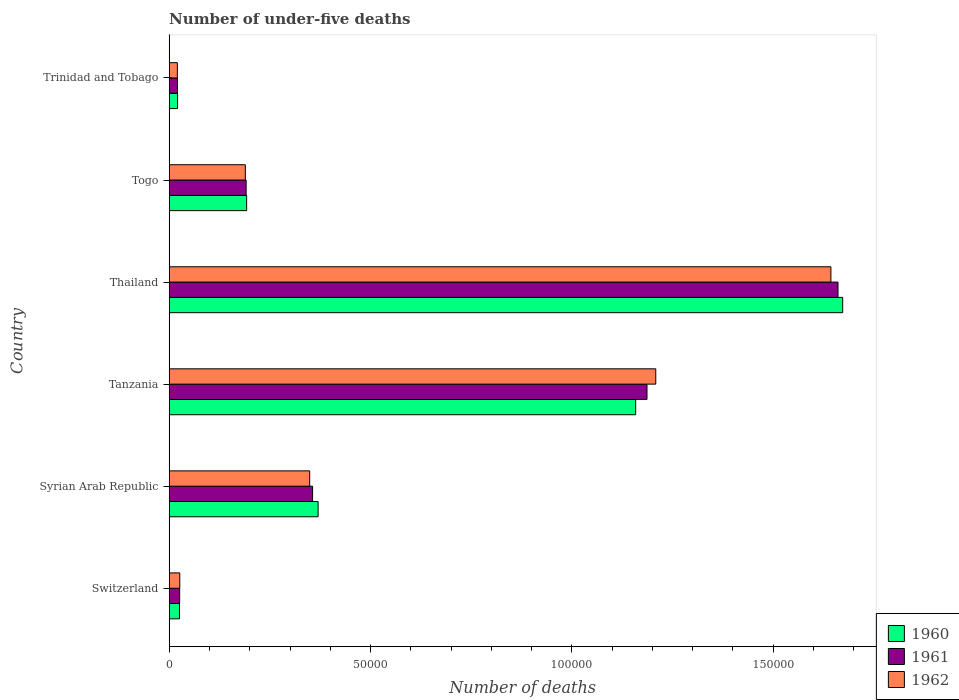Are the number of bars on each tick of the Y-axis equal?
Your answer should be very brief. Yes. How many bars are there on the 2nd tick from the bottom?
Your answer should be compact. 3. What is the label of the 2nd group of bars from the top?
Offer a terse response. Togo. What is the number of under-five deaths in 1962 in Thailand?
Your response must be concise. 1.64e+05. Across all countries, what is the maximum number of under-five deaths in 1961?
Your answer should be very brief. 1.66e+05. Across all countries, what is the minimum number of under-five deaths in 1962?
Offer a terse response. 2020. In which country was the number of under-five deaths in 1961 maximum?
Offer a very short reply. Thailand. In which country was the number of under-five deaths in 1961 minimum?
Keep it short and to the point. Trinidad and Tobago. What is the total number of under-five deaths in 1960 in the graph?
Your answer should be compact. 3.44e+05. What is the difference between the number of under-five deaths in 1961 in Switzerland and that in Tanzania?
Your answer should be compact. -1.16e+05. What is the difference between the number of under-five deaths in 1960 in Thailand and the number of under-five deaths in 1962 in Tanzania?
Provide a succinct answer. 4.64e+04. What is the average number of under-five deaths in 1962 per country?
Give a very brief answer. 5.73e+04. What is the difference between the number of under-five deaths in 1962 and number of under-five deaths in 1961 in Thailand?
Your answer should be compact. -1764. What is the ratio of the number of under-five deaths in 1962 in Switzerland to that in Tanzania?
Provide a short and direct response. 0.02. Is the difference between the number of under-five deaths in 1962 in Thailand and Togo greater than the difference between the number of under-five deaths in 1961 in Thailand and Togo?
Your response must be concise. No. What is the difference between the highest and the second highest number of under-five deaths in 1960?
Make the answer very short. 5.14e+04. What is the difference between the highest and the lowest number of under-five deaths in 1962?
Offer a terse response. 1.62e+05. Is the sum of the number of under-five deaths in 1962 in Syrian Arab Republic and Tanzania greater than the maximum number of under-five deaths in 1960 across all countries?
Your answer should be very brief. No. What does the 1st bar from the top in Syrian Arab Republic represents?
Keep it short and to the point. 1962. Is it the case that in every country, the sum of the number of under-five deaths in 1961 and number of under-five deaths in 1962 is greater than the number of under-five deaths in 1960?
Your response must be concise. Yes. Are all the bars in the graph horizontal?
Give a very brief answer. Yes. How many countries are there in the graph?
Give a very brief answer. 6. Does the graph contain any zero values?
Make the answer very short. No. Where does the legend appear in the graph?
Give a very brief answer. Bottom right. How many legend labels are there?
Your answer should be compact. 3. What is the title of the graph?
Your answer should be compact. Number of under-five deaths. Does "2015" appear as one of the legend labels in the graph?
Give a very brief answer. No. What is the label or title of the X-axis?
Your response must be concise. Number of deaths. What is the Number of deaths in 1960 in Switzerland?
Give a very brief answer. 2549. What is the Number of deaths in 1961 in Switzerland?
Your answer should be compact. 2598. What is the Number of deaths of 1962 in Switzerland?
Your response must be concise. 2625. What is the Number of deaths of 1960 in Syrian Arab Republic?
Keep it short and to the point. 3.70e+04. What is the Number of deaths in 1961 in Syrian Arab Republic?
Ensure brevity in your answer.  3.56e+04. What is the Number of deaths of 1962 in Syrian Arab Republic?
Your answer should be very brief. 3.49e+04. What is the Number of deaths of 1960 in Tanzania?
Keep it short and to the point. 1.16e+05. What is the Number of deaths in 1961 in Tanzania?
Offer a very short reply. 1.19e+05. What is the Number of deaths in 1962 in Tanzania?
Make the answer very short. 1.21e+05. What is the Number of deaths of 1960 in Thailand?
Provide a short and direct response. 1.67e+05. What is the Number of deaths in 1961 in Thailand?
Your response must be concise. 1.66e+05. What is the Number of deaths in 1962 in Thailand?
Make the answer very short. 1.64e+05. What is the Number of deaths in 1960 in Togo?
Your answer should be very brief. 1.92e+04. What is the Number of deaths of 1961 in Togo?
Make the answer very short. 1.91e+04. What is the Number of deaths of 1962 in Togo?
Offer a very short reply. 1.89e+04. What is the Number of deaths of 1960 in Trinidad and Tobago?
Your response must be concise. 2077. What is the Number of deaths in 1961 in Trinidad and Tobago?
Provide a succinct answer. 2047. What is the Number of deaths of 1962 in Trinidad and Tobago?
Provide a short and direct response. 2020. Across all countries, what is the maximum Number of deaths in 1960?
Offer a very short reply. 1.67e+05. Across all countries, what is the maximum Number of deaths in 1961?
Your answer should be very brief. 1.66e+05. Across all countries, what is the maximum Number of deaths in 1962?
Offer a terse response. 1.64e+05. Across all countries, what is the minimum Number of deaths in 1960?
Give a very brief answer. 2077. Across all countries, what is the minimum Number of deaths of 1961?
Your answer should be compact. 2047. Across all countries, what is the minimum Number of deaths in 1962?
Give a very brief answer. 2020. What is the total Number of deaths of 1960 in the graph?
Your answer should be compact. 3.44e+05. What is the total Number of deaths in 1961 in the graph?
Your response must be concise. 3.44e+05. What is the total Number of deaths of 1962 in the graph?
Provide a succinct answer. 3.44e+05. What is the difference between the Number of deaths of 1960 in Switzerland and that in Syrian Arab Republic?
Offer a terse response. -3.44e+04. What is the difference between the Number of deaths of 1961 in Switzerland and that in Syrian Arab Republic?
Give a very brief answer. -3.30e+04. What is the difference between the Number of deaths in 1962 in Switzerland and that in Syrian Arab Republic?
Give a very brief answer. -3.23e+04. What is the difference between the Number of deaths of 1960 in Switzerland and that in Tanzania?
Make the answer very short. -1.13e+05. What is the difference between the Number of deaths in 1961 in Switzerland and that in Tanzania?
Your answer should be very brief. -1.16e+05. What is the difference between the Number of deaths in 1962 in Switzerland and that in Tanzania?
Keep it short and to the point. -1.18e+05. What is the difference between the Number of deaths of 1960 in Switzerland and that in Thailand?
Provide a succinct answer. -1.65e+05. What is the difference between the Number of deaths in 1961 in Switzerland and that in Thailand?
Your answer should be compact. -1.63e+05. What is the difference between the Number of deaths of 1962 in Switzerland and that in Thailand?
Provide a short and direct response. -1.62e+05. What is the difference between the Number of deaths in 1960 in Switzerland and that in Togo?
Keep it short and to the point. -1.67e+04. What is the difference between the Number of deaths in 1961 in Switzerland and that in Togo?
Ensure brevity in your answer.  -1.65e+04. What is the difference between the Number of deaths in 1962 in Switzerland and that in Togo?
Make the answer very short. -1.63e+04. What is the difference between the Number of deaths of 1960 in Switzerland and that in Trinidad and Tobago?
Offer a terse response. 472. What is the difference between the Number of deaths of 1961 in Switzerland and that in Trinidad and Tobago?
Offer a very short reply. 551. What is the difference between the Number of deaths in 1962 in Switzerland and that in Trinidad and Tobago?
Keep it short and to the point. 605. What is the difference between the Number of deaths in 1960 in Syrian Arab Republic and that in Tanzania?
Provide a short and direct response. -7.89e+04. What is the difference between the Number of deaths in 1961 in Syrian Arab Republic and that in Tanzania?
Provide a succinct answer. -8.30e+04. What is the difference between the Number of deaths of 1962 in Syrian Arab Republic and that in Tanzania?
Provide a succinct answer. -8.59e+04. What is the difference between the Number of deaths in 1960 in Syrian Arab Republic and that in Thailand?
Your response must be concise. -1.30e+05. What is the difference between the Number of deaths in 1961 in Syrian Arab Republic and that in Thailand?
Your response must be concise. -1.30e+05. What is the difference between the Number of deaths in 1962 in Syrian Arab Republic and that in Thailand?
Your answer should be very brief. -1.29e+05. What is the difference between the Number of deaths of 1960 in Syrian Arab Republic and that in Togo?
Your response must be concise. 1.78e+04. What is the difference between the Number of deaths in 1961 in Syrian Arab Republic and that in Togo?
Your answer should be compact. 1.65e+04. What is the difference between the Number of deaths of 1962 in Syrian Arab Republic and that in Togo?
Your response must be concise. 1.60e+04. What is the difference between the Number of deaths in 1960 in Syrian Arab Republic and that in Trinidad and Tobago?
Your response must be concise. 3.49e+04. What is the difference between the Number of deaths of 1961 in Syrian Arab Republic and that in Trinidad and Tobago?
Your response must be concise. 3.36e+04. What is the difference between the Number of deaths in 1962 in Syrian Arab Republic and that in Trinidad and Tobago?
Ensure brevity in your answer.  3.29e+04. What is the difference between the Number of deaths in 1960 in Tanzania and that in Thailand?
Ensure brevity in your answer.  -5.14e+04. What is the difference between the Number of deaths in 1961 in Tanzania and that in Thailand?
Give a very brief answer. -4.74e+04. What is the difference between the Number of deaths of 1962 in Tanzania and that in Thailand?
Offer a very short reply. -4.35e+04. What is the difference between the Number of deaths in 1960 in Tanzania and that in Togo?
Your response must be concise. 9.66e+04. What is the difference between the Number of deaths of 1961 in Tanzania and that in Togo?
Your answer should be very brief. 9.95e+04. What is the difference between the Number of deaths in 1962 in Tanzania and that in Togo?
Your answer should be compact. 1.02e+05. What is the difference between the Number of deaths of 1960 in Tanzania and that in Trinidad and Tobago?
Offer a very short reply. 1.14e+05. What is the difference between the Number of deaths in 1961 in Tanzania and that in Trinidad and Tobago?
Give a very brief answer. 1.17e+05. What is the difference between the Number of deaths of 1962 in Tanzania and that in Trinidad and Tobago?
Make the answer very short. 1.19e+05. What is the difference between the Number of deaths of 1960 in Thailand and that in Togo?
Provide a succinct answer. 1.48e+05. What is the difference between the Number of deaths in 1961 in Thailand and that in Togo?
Keep it short and to the point. 1.47e+05. What is the difference between the Number of deaths in 1962 in Thailand and that in Togo?
Provide a short and direct response. 1.45e+05. What is the difference between the Number of deaths of 1960 in Thailand and that in Trinidad and Tobago?
Offer a very short reply. 1.65e+05. What is the difference between the Number of deaths of 1961 in Thailand and that in Trinidad and Tobago?
Your answer should be very brief. 1.64e+05. What is the difference between the Number of deaths in 1962 in Thailand and that in Trinidad and Tobago?
Ensure brevity in your answer.  1.62e+05. What is the difference between the Number of deaths of 1960 in Togo and that in Trinidad and Tobago?
Make the answer very short. 1.72e+04. What is the difference between the Number of deaths in 1961 in Togo and that in Trinidad and Tobago?
Ensure brevity in your answer.  1.71e+04. What is the difference between the Number of deaths in 1962 in Togo and that in Trinidad and Tobago?
Give a very brief answer. 1.69e+04. What is the difference between the Number of deaths in 1960 in Switzerland and the Number of deaths in 1961 in Syrian Arab Republic?
Provide a succinct answer. -3.31e+04. What is the difference between the Number of deaths in 1960 in Switzerland and the Number of deaths in 1962 in Syrian Arab Republic?
Provide a succinct answer. -3.23e+04. What is the difference between the Number of deaths in 1961 in Switzerland and the Number of deaths in 1962 in Syrian Arab Republic?
Provide a short and direct response. -3.23e+04. What is the difference between the Number of deaths in 1960 in Switzerland and the Number of deaths in 1961 in Tanzania?
Offer a very short reply. -1.16e+05. What is the difference between the Number of deaths of 1960 in Switzerland and the Number of deaths of 1962 in Tanzania?
Make the answer very short. -1.18e+05. What is the difference between the Number of deaths in 1961 in Switzerland and the Number of deaths in 1962 in Tanzania?
Offer a very short reply. -1.18e+05. What is the difference between the Number of deaths of 1960 in Switzerland and the Number of deaths of 1961 in Thailand?
Ensure brevity in your answer.  -1.64e+05. What is the difference between the Number of deaths of 1960 in Switzerland and the Number of deaths of 1962 in Thailand?
Offer a terse response. -1.62e+05. What is the difference between the Number of deaths in 1961 in Switzerland and the Number of deaths in 1962 in Thailand?
Keep it short and to the point. -1.62e+05. What is the difference between the Number of deaths of 1960 in Switzerland and the Number of deaths of 1961 in Togo?
Keep it short and to the point. -1.66e+04. What is the difference between the Number of deaths of 1960 in Switzerland and the Number of deaths of 1962 in Togo?
Keep it short and to the point. -1.64e+04. What is the difference between the Number of deaths of 1961 in Switzerland and the Number of deaths of 1962 in Togo?
Make the answer very short. -1.63e+04. What is the difference between the Number of deaths of 1960 in Switzerland and the Number of deaths of 1961 in Trinidad and Tobago?
Give a very brief answer. 502. What is the difference between the Number of deaths of 1960 in Switzerland and the Number of deaths of 1962 in Trinidad and Tobago?
Give a very brief answer. 529. What is the difference between the Number of deaths of 1961 in Switzerland and the Number of deaths of 1962 in Trinidad and Tobago?
Provide a short and direct response. 578. What is the difference between the Number of deaths of 1960 in Syrian Arab Republic and the Number of deaths of 1961 in Tanzania?
Make the answer very short. -8.17e+04. What is the difference between the Number of deaths in 1960 in Syrian Arab Republic and the Number of deaths in 1962 in Tanzania?
Your answer should be compact. -8.38e+04. What is the difference between the Number of deaths in 1961 in Syrian Arab Republic and the Number of deaths in 1962 in Tanzania?
Give a very brief answer. -8.52e+04. What is the difference between the Number of deaths in 1960 in Syrian Arab Republic and the Number of deaths in 1961 in Thailand?
Make the answer very short. -1.29e+05. What is the difference between the Number of deaths of 1960 in Syrian Arab Republic and the Number of deaths of 1962 in Thailand?
Ensure brevity in your answer.  -1.27e+05. What is the difference between the Number of deaths in 1961 in Syrian Arab Republic and the Number of deaths in 1962 in Thailand?
Give a very brief answer. -1.29e+05. What is the difference between the Number of deaths in 1960 in Syrian Arab Republic and the Number of deaths in 1961 in Togo?
Your response must be concise. 1.79e+04. What is the difference between the Number of deaths in 1960 in Syrian Arab Republic and the Number of deaths in 1962 in Togo?
Offer a terse response. 1.81e+04. What is the difference between the Number of deaths in 1961 in Syrian Arab Republic and the Number of deaths in 1962 in Togo?
Your answer should be very brief. 1.67e+04. What is the difference between the Number of deaths in 1960 in Syrian Arab Republic and the Number of deaths in 1961 in Trinidad and Tobago?
Offer a very short reply. 3.49e+04. What is the difference between the Number of deaths in 1960 in Syrian Arab Republic and the Number of deaths in 1962 in Trinidad and Tobago?
Your answer should be very brief. 3.50e+04. What is the difference between the Number of deaths in 1961 in Syrian Arab Republic and the Number of deaths in 1962 in Trinidad and Tobago?
Provide a succinct answer. 3.36e+04. What is the difference between the Number of deaths in 1960 in Tanzania and the Number of deaths in 1961 in Thailand?
Give a very brief answer. -5.02e+04. What is the difference between the Number of deaths in 1960 in Tanzania and the Number of deaths in 1962 in Thailand?
Give a very brief answer. -4.85e+04. What is the difference between the Number of deaths of 1961 in Tanzania and the Number of deaths of 1962 in Thailand?
Keep it short and to the point. -4.57e+04. What is the difference between the Number of deaths of 1960 in Tanzania and the Number of deaths of 1961 in Togo?
Offer a very short reply. 9.67e+04. What is the difference between the Number of deaths in 1960 in Tanzania and the Number of deaths in 1962 in Togo?
Provide a short and direct response. 9.69e+04. What is the difference between the Number of deaths in 1961 in Tanzania and the Number of deaths in 1962 in Togo?
Your response must be concise. 9.97e+04. What is the difference between the Number of deaths of 1960 in Tanzania and the Number of deaths of 1961 in Trinidad and Tobago?
Offer a terse response. 1.14e+05. What is the difference between the Number of deaths in 1960 in Tanzania and the Number of deaths in 1962 in Trinidad and Tobago?
Offer a terse response. 1.14e+05. What is the difference between the Number of deaths of 1961 in Tanzania and the Number of deaths of 1962 in Trinidad and Tobago?
Ensure brevity in your answer.  1.17e+05. What is the difference between the Number of deaths of 1960 in Thailand and the Number of deaths of 1961 in Togo?
Provide a succinct answer. 1.48e+05. What is the difference between the Number of deaths of 1960 in Thailand and the Number of deaths of 1962 in Togo?
Keep it short and to the point. 1.48e+05. What is the difference between the Number of deaths in 1961 in Thailand and the Number of deaths in 1962 in Togo?
Give a very brief answer. 1.47e+05. What is the difference between the Number of deaths in 1960 in Thailand and the Number of deaths in 1961 in Trinidad and Tobago?
Offer a terse response. 1.65e+05. What is the difference between the Number of deaths in 1960 in Thailand and the Number of deaths in 1962 in Trinidad and Tobago?
Give a very brief answer. 1.65e+05. What is the difference between the Number of deaths in 1961 in Thailand and the Number of deaths in 1962 in Trinidad and Tobago?
Provide a succinct answer. 1.64e+05. What is the difference between the Number of deaths of 1960 in Togo and the Number of deaths of 1961 in Trinidad and Tobago?
Give a very brief answer. 1.72e+04. What is the difference between the Number of deaths in 1960 in Togo and the Number of deaths in 1962 in Trinidad and Tobago?
Your response must be concise. 1.72e+04. What is the difference between the Number of deaths in 1961 in Togo and the Number of deaths in 1962 in Trinidad and Tobago?
Ensure brevity in your answer.  1.71e+04. What is the average Number of deaths of 1960 per country?
Keep it short and to the point. 5.73e+04. What is the average Number of deaths of 1961 per country?
Give a very brief answer. 5.73e+04. What is the average Number of deaths of 1962 per country?
Ensure brevity in your answer.  5.73e+04. What is the difference between the Number of deaths of 1960 and Number of deaths of 1961 in Switzerland?
Your response must be concise. -49. What is the difference between the Number of deaths in 1960 and Number of deaths in 1962 in Switzerland?
Make the answer very short. -76. What is the difference between the Number of deaths in 1961 and Number of deaths in 1962 in Switzerland?
Keep it short and to the point. -27. What is the difference between the Number of deaths in 1960 and Number of deaths in 1961 in Syrian Arab Republic?
Your response must be concise. 1372. What is the difference between the Number of deaths in 1960 and Number of deaths in 1962 in Syrian Arab Republic?
Give a very brief answer. 2094. What is the difference between the Number of deaths of 1961 and Number of deaths of 1962 in Syrian Arab Republic?
Make the answer very short. 722. What is the difference between the Number of deaths of 1960 and Number of deaths of 1961 in Tanzania?
Your answer should be very brief. -2813. What is the difference between the Number of deaths in 1960 and Number of deaths in 1962 in Tanzania?
Your answer should be very brief. -4990. What is the difference between the Number of deaths of 1961 and Number of deaths of 1962 in Tanzania?
Your answer should be very brief. -2177. What is the difference between the Number of deaths in 1960 and Number of deaths in 1961 in Thailand?
Offer a very short reply. 1164. What is the difference between the Number of deaths in 1960 and Number of deaths in 1962 in Thailand?
Make the answer very short. 2928. What is the difference between the Number of deaths of 1961 and Number of deaths of 1962 in Thailand?
Your answer should be very brief. 1764. What is the difference between the Number of deaths in 1960 and Number of deaths in 1961 in Togo?
Ensure brevity in your answer.  125. What is the difference between the Number of deaths in 1960 and Number of deaths in 1962 in Togo?
Offer a very short reply. 326. What is the difference between the Number of deaths in 1961 and Number of deaths in 1962 in Togo?
Your answer should be very brief. 201. What is the difference between the Number of deaths of 1960 and Number of deaths of 1962 in Trinidad and Tobago?
Provide a succinct answer. 57. What is the ratio of the Number of deaths of 1960 in Switzerland to that in Syrian Arab Republic?
Keep it short and to the point. 0.07. What is the ratio of the Number of deaths of 1961 in Switzerland to that in Syrian Arab Republic?
Provide a succinct answer. 0.07. What is the ratio of the Number of deaths in 1962 in Switzerland to that in Syrian Arab Republic?
Make the answer very short. 0.08. What is the ratio of the Number of deaths in 1960 in Switzerland to that in Tanzania?
Provide a short and direct response. 0.02. What is the ratio of the Number of deaths of 1961 in Switzerland to that in Tanzania?
Give a very brief answer. 0.02. What is the ratio of the Number of deaths of 1962 in Switzerland to that in Tanzania?
Provide a short and direct response. 0.02. What is the ratio of the Number of deaths in 1960 in Switzerland to that in Thailand?
Your answer should be compact. 0.02. What is the ratio of the Number of deaths in 1961 in Switzerland to that in Thailand?
Provide a short and direct response. 0.02. What is the ratio of the Number of deaths in 1962 in Switzerland to that in Thailand?
Your answer should be compact. 0.02. What is the ratio of the Number of deaths in 1960 in Switzerland to that in Togo?
Keep it short and to the point. 0.13. What is the ratio of the Number of deaths of 1961 in Switzerland to that in Togo?
Offer a very short reply. 0.14. What is the ratio of the Number of deaths of 1962 in Switzerland to that in Togo?
Ensure brevity in your answer.  0.14. What is the ratio of the Number of deaths of 1960 in Switzerland to that in Trinidad and Tobago?
Offer a terse response. 1.23. What is the ratio of the Number of deaths in 1961 in Switzerland to that in Trinidad and Tobago?
Provide a short and direct response. 1.27. What is the ratio of the Number of deaths of 1962 in Switzerland to that in Trinidad and Tobago?
Make the answer very short. 1.3. What is the ratio of the Number of deaths of 1960 in Syrian Arab Republic to that in Tanzania?
Give a very brief answer. 0.32. What is the ratio of the Number of deaths in 1961 in Syrian Arab Republic to that in Tanzania?
Offer a terse response. 0.3. What is the ratio of the Number of deaths of 1962 in Syrian Arab Republic to that in Tanzania?
Offer a terse response. 0.29. What is the ratio of the Number of deaths in 1960 in Syrian Arab Republic to that in Thailand?
Your response must be concise. 0.22. What is the ratio of the Number of deaths of 1961 in Syrian Arab Republic to that in Thailand?
Make the answer very short. 0.21. What is the ratio of the Number of deaths in 1962 in Syrian Arab Republic to that in Thailand?
Provide a short and direct response. 0.21. What is the ratio of the Number of deaths in 1960 in Syrian Arab Republic to that in Togo?
Make the answer very short. 1.92. What is the ratio of the Number of deaths in 1961 in Syrian Arab Republic to that in Togo?
Offer a very short reply. 1.86. What is the ratio of the Number of deaths of 1962 in Syrian Arab Republic to that in Togo?
Offer a very short reply. 1.85. What is the ratio of the Number of deaths in 1960 in Syrian Arab Republic to that in Trinidad and Tobago?
Give a very brief answer. 17.8. What is the ratio of the Number of deaths in 1961 in Syrian Arab Republic to that in Trinidad and Tobago?
Offer a terse response. 17.39. What is the ratio of the Number of deaths of 1962 in Syrian Arab Republic to that in Trinidad and Tobago?
Your answer should be compact. 17.27. What is the ratio of the Number of deaths in 1960 in Tanzania to that in Thailand?
Keep it short and to the point. 0.69. What is the ratio of the Number of deaths in 1961 in Tanzania to that in Thailand?
Your answer should be compact. 0.71. What is the ratio of the Number of deaths in 1962 in Tanzania to that in Thailand?
Your answer should be very brief. 0.74. What is the ratio of the Number of deaths in 1960 in Tanzania to that in Togo?
Offer a very short reply. 6.02. What is the ratio of the Number of deaths in 1961 in Tanzania to that in Togo?
Offer a very short reply. 6.21. What is the ratio of the Number of deaths in 1962 in Tanzania to that in Togo?
Provide a short and direct response. 6.39. What is the ratio of the Number of deaths in 1960 in Tanzania to that in Trinidad and Tobago?
Offer a terse response. 55.77. What is the ratio of the Number of deaths of 1961 in Tanzania to that in Trinidad and Tobago?
Keep it short and to the point. 57.96. What is the ratio of the Number of deaths of 1962 in Tanzania to that in Trinidad and Tobago?
Your answer should be very brief. 59.82. What is the ratio of the Number of deaths of 1960 in Thailand to that in Togo?
Provide a short and direct response. 8.7. What is the ratio of the Number of deaths of 1961 in Thailand to that in Togo?
Provide a succinct answer. 8.69. What is the ratio of the Number of deaths in 1962 in Thailand to that in Togo?
Give a very brief answer. 8.69. What is the ratio of the Number of deaths of 1960 in Thailand to that in Trinidad and Tobago?
Give a very brief answer. 80.52. What is the ratio of the Number of deaths of 1961 in Thailand to that in Trinidad and Tobago?
Your answer should be compact. 81.14. What is the ratio of the Number of deaths of 1962 in Thailand to that in Trinidad and Tobago?
Your answer should be very brief. 81.35. What is the ratio of the Number of deaths in 1960 in Togo to that in Trinidad and Tobago?
Make the answer very short. 9.26. What is the ratio of the Number of deaths of 1961 in Togo to that in Trinidad and Tobago?
Offer a very short reply. 9.33. What is the ratio of the Number of deaths in 1962 in Togo to that in Trinidad and Tobago?
Offer a very short reply. 9.36. What is the difference between the highest and the second highest Number of deaths of 1960?
Ensure brevity in your answer.  5.14e+04. What is the difference between the highest and the second highest Number of deaths of 1961?
Make the answer very short. 4.74e+04. What is the difference between the highest and the second highest Number of deaths in 1962?
Your response must be concise. 4.35e+04. What is the difference between the highest and the lowest Number of deaths of 1960?
Provide a short and direct response. 1.65e+05. What is the difference between the highest and the lowest Number of deaths of 1961?
Your answer should be very brief. 1.64e+05. What is the difference between the highest and the lowest Number of deaths in 1962?
Keep it short and to the point. 1.62e+05. 